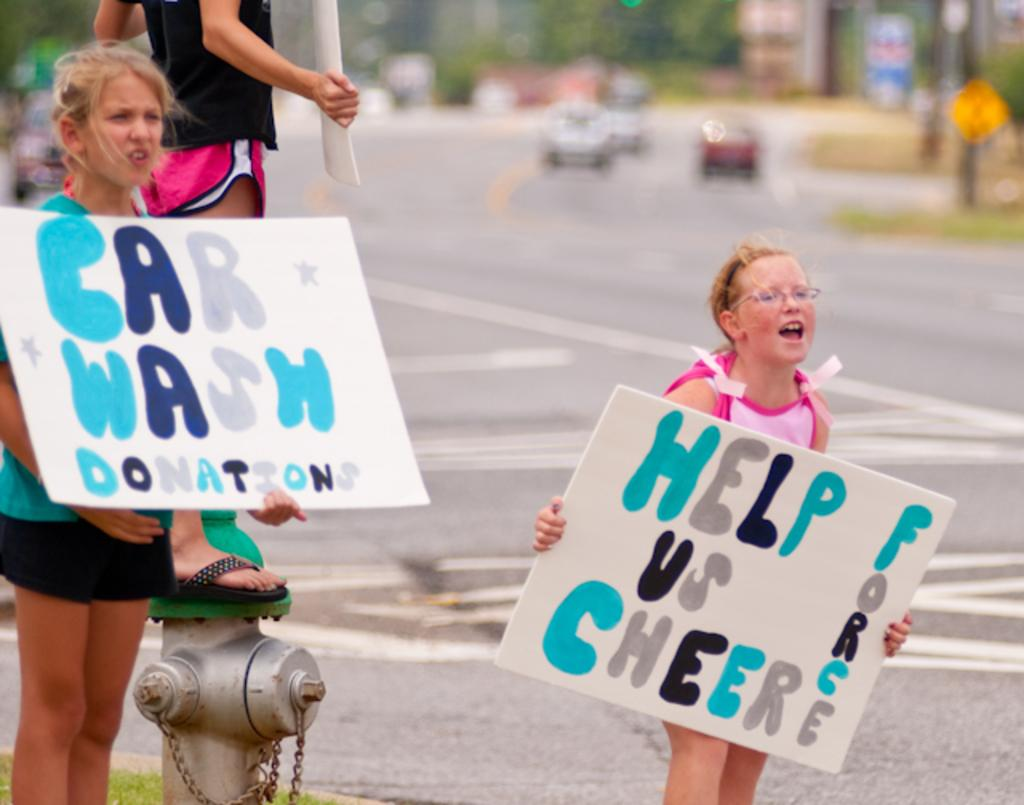How many kids are present in the image? There are three kids in the image. What are the kids holding in their hands? The kids are holding posters in their hands. What can be seen on the posters? There is text written on the posters. Can you describe the background of the image? The background of the image is blurred. What type of neck accessory is visible on the kids in the image? There is no neck accessory visible on the kids in the image. Can you see a window in the background of the image? There is no window visible in the background of the image; it is blurred. 